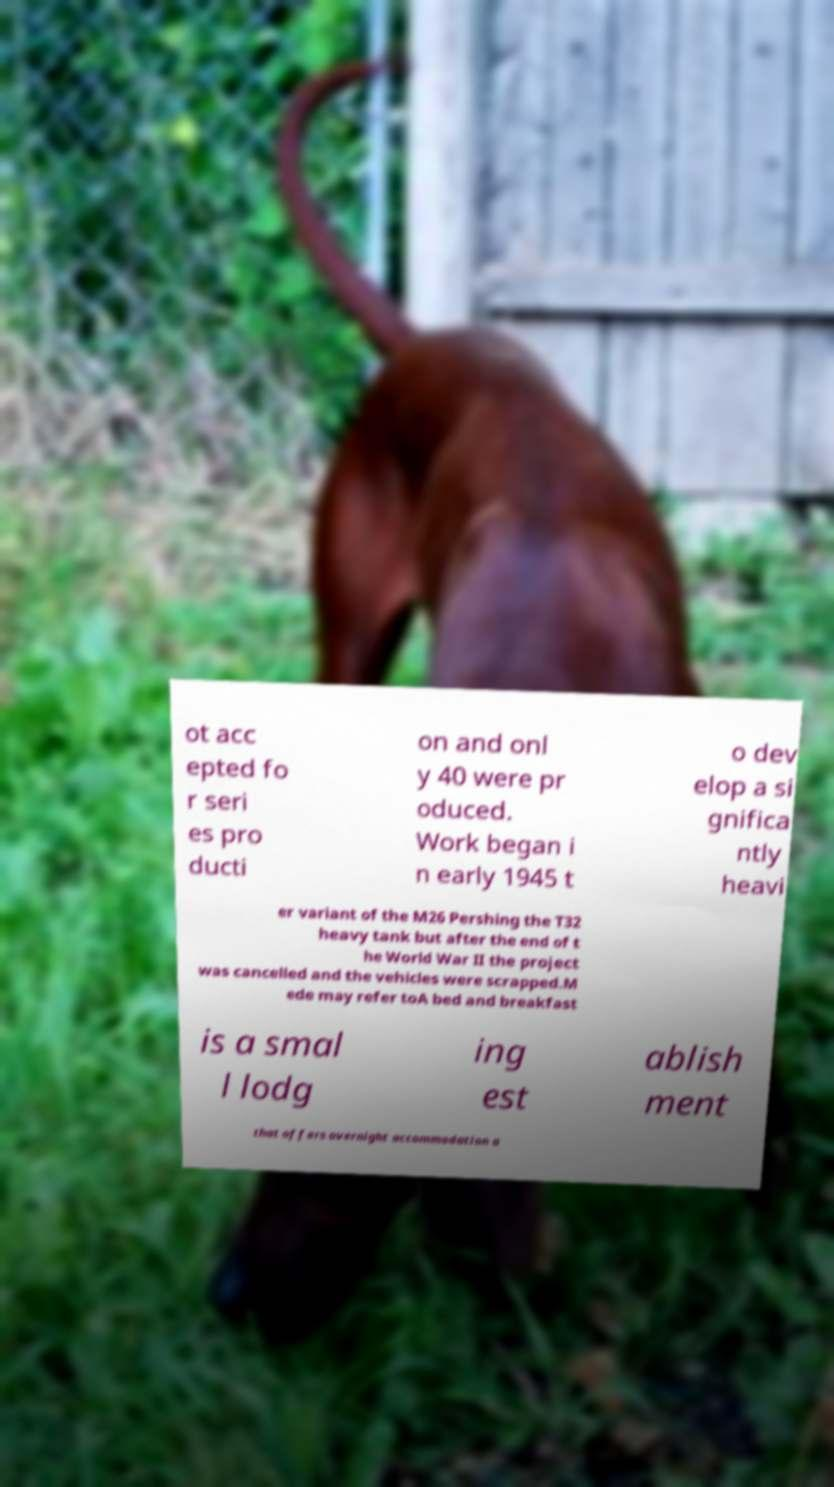For documentation purposes, I need the text within this image transcribed. Could you provide that? ot acc epted fo r seri es pro ducti on and onl y 40 were pr oduced. Work began i n early 1945 t o dev elop a si gnifica ntly heavi er variant of the M26 Pershing the T32 heavy tank but after the end of t he World War II the project was cancelled and the vehicles were scrapped.M ede may refer toA bed and breakfast is a smal l lodg ing est ablish ment that offers overnight accommodation a 